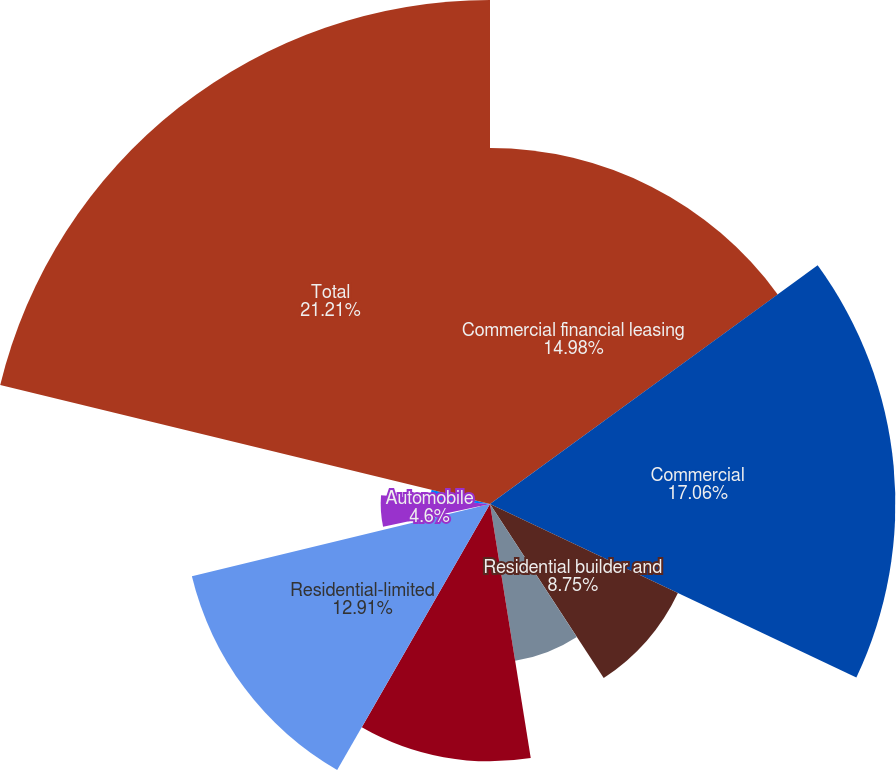Convert chart. <chart><loc_0><loc_0><loc_500><loc_500><pie_chart><fcel>Commercial financial leasing<fcel>Commercial<fcel>Residential builder and<fcel>Other commercial construction<fcel>Residential<fcel>Residential-limited<fcel>Home equity lines and loans<fcel>Automobile<fcel>Other<fcel>Total<nl><fcel>14.98%<fcel>17.06%<fcel>8.75%<fcel>6.68%<fcel>10.83%<fcel>12.91%<fcel>0.45%<fcel>4.6%<fcel>2.53%<fcel>21.21%<nl></chart> 